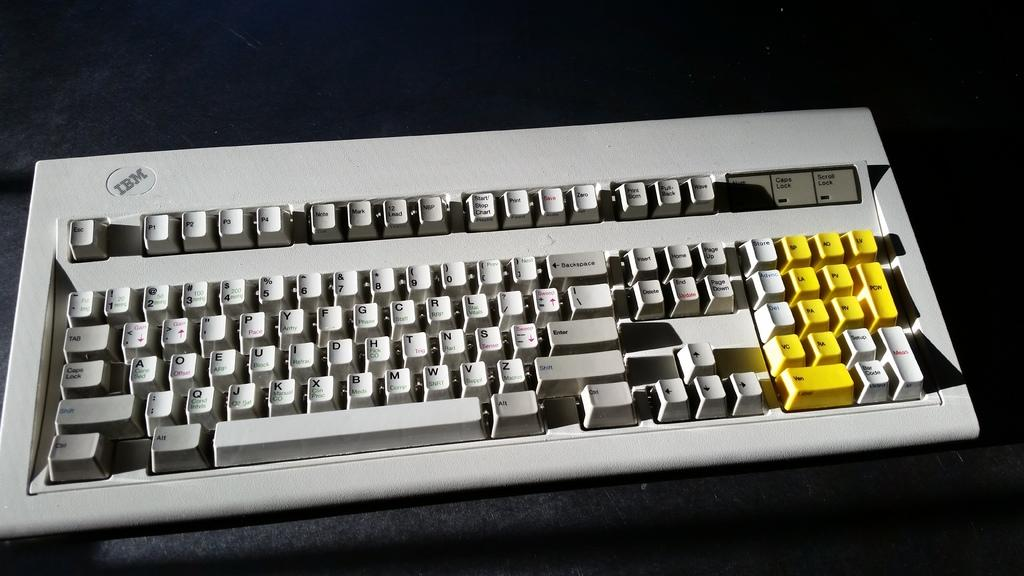Provide a one-sentence caption for the provided image. One of the first keyboards made by IBM. 